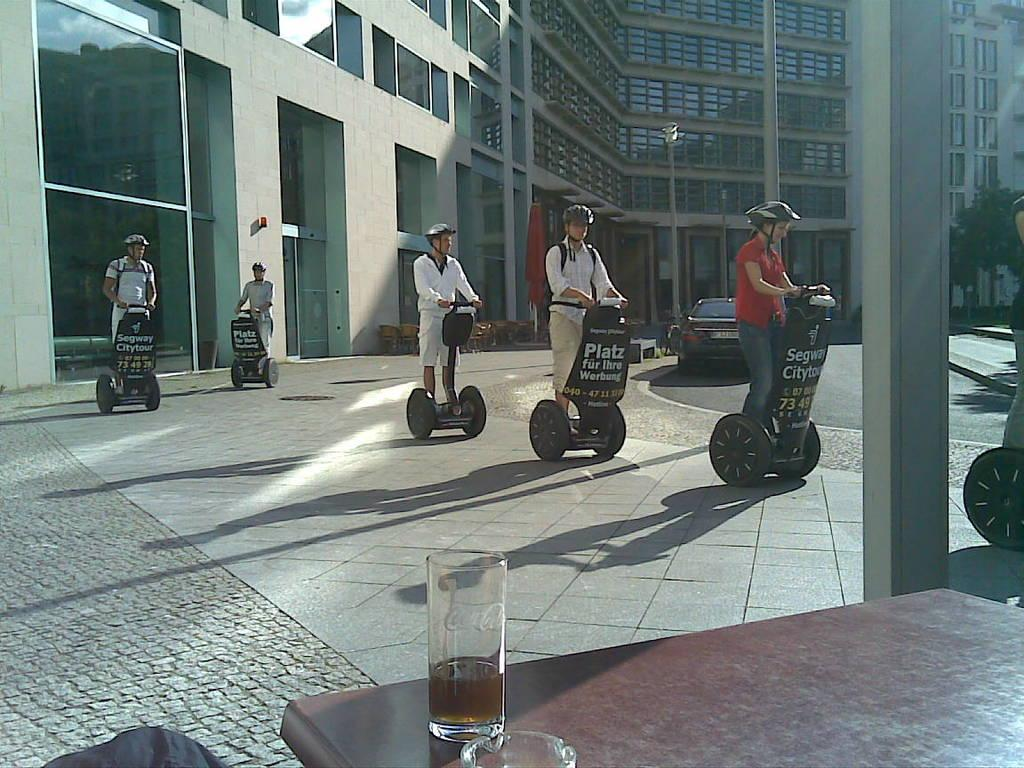What are the people riding in the image? The people are riding hoverboards in the image. What safety equipment are the people wearing? The people are wearing helmets in the image. What can be seen on the table in the image? There are glasses on the table in the image. What objects can be seen in the background of the image? In the background, there is a building, another pole, chairs, a flag, and trees. How many eggs are being used to decorate the legs of the people in the image? There are no eggs or references to legs in the image; the people are wearing helmets and riding hoverboards. What type of birthday celebration is taking place in the image? There is no indication of a birthday celebration in the image. 